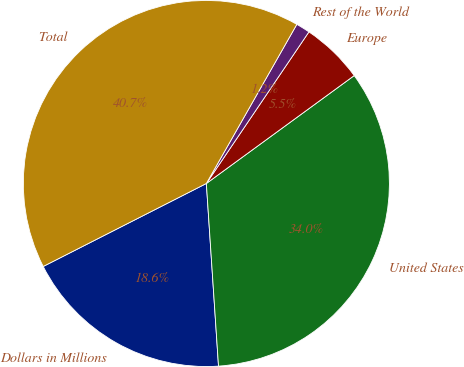Convert chart. <chart><loc_0><loc_0><loc_500><loc_500><pie_chart><fcel>Dollars in Millions<fcel>United States<fcel>Europe<fcel>Rest of the World<fcel>Total<nl><fcel>18.57%<fcel>33.98%<fcel>5.5%<fcel>1.24%<fcel>40.72%<nl></chart> 